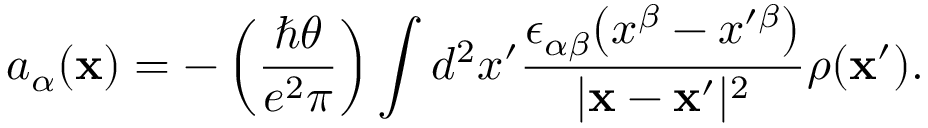Convert formula to latex. <formula><loc_0><loc_0><loc_500><loc_500>a _ { \alpha } ( { x } ) = - \left ( { \frac { \hbar { \theta } } { e ^ { 2 } \pi } } \right ) \int d ^ { 2 } x ^ { \prime } { \frac { \epsilon _ { \alpha \beta } \left ( x ^ { \beta } - x ^ { \prime \beta } \right ) } { | { x } - { x } ^ { \prime } | ^ { 2 } } } \rho ( { x } ^ { \prime } ) .</formula> 